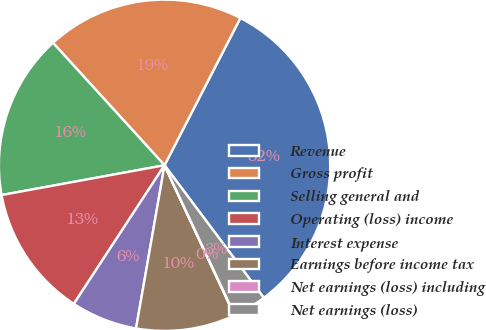<chart> <loc_0><loc_0><loc_500><loc_500><pie_chart><fcel>Revenue<fcel>Gross profit<fcel>Selling general and<fcel>Operating (loss) income<fcel>Interest expense<fcel>Earnings before income tax<fcel>Net earnings (loss) including<fcel>Net earnings (loss)<nl><fcel>32.2%<fcel>19.33%<fcel>16.12%<fcel>12.9%<fcel>6.47%<fcel>9.69%<fcel>0.04%<fcel>3.25%<nl></chart> 